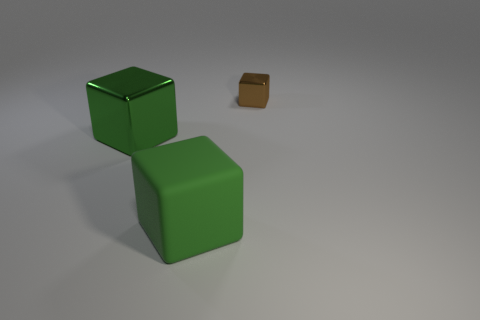Add 1 shiny objects. How many objects exist? 4 Add 3 big green objects. How many big green objects are left? 5 Add 1 tiny brown blocks. How many tiny brown blocks exist? 2 Subtract all green blocks. How many blocks are left? 1 Subtract all big green blocks. How many blocks are left? 1 Subtract 0 gray blocks. How many objects are left? 3 Subtract all cyan cubes. Subtract all brown spheres. How many cubes are left? 3 Subtract all gray balls. How many brown blocks are left? 1 Subtract all small blue rubber objects. Subtract all big shiny blocks. How many objects are left? 2 